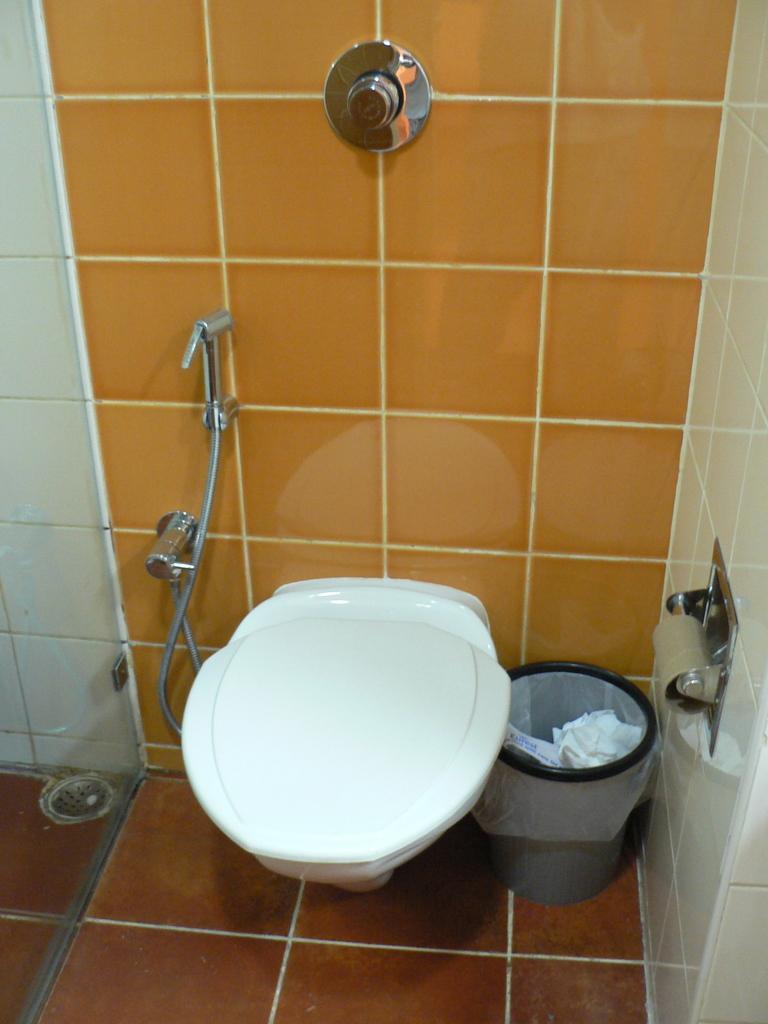In one or two sentences, can you explain what this image depicts? This is the inner view of the washroom. In the washroom we can see flush button, walls, bin, tissue holder, toilet seat and a hand shower. 